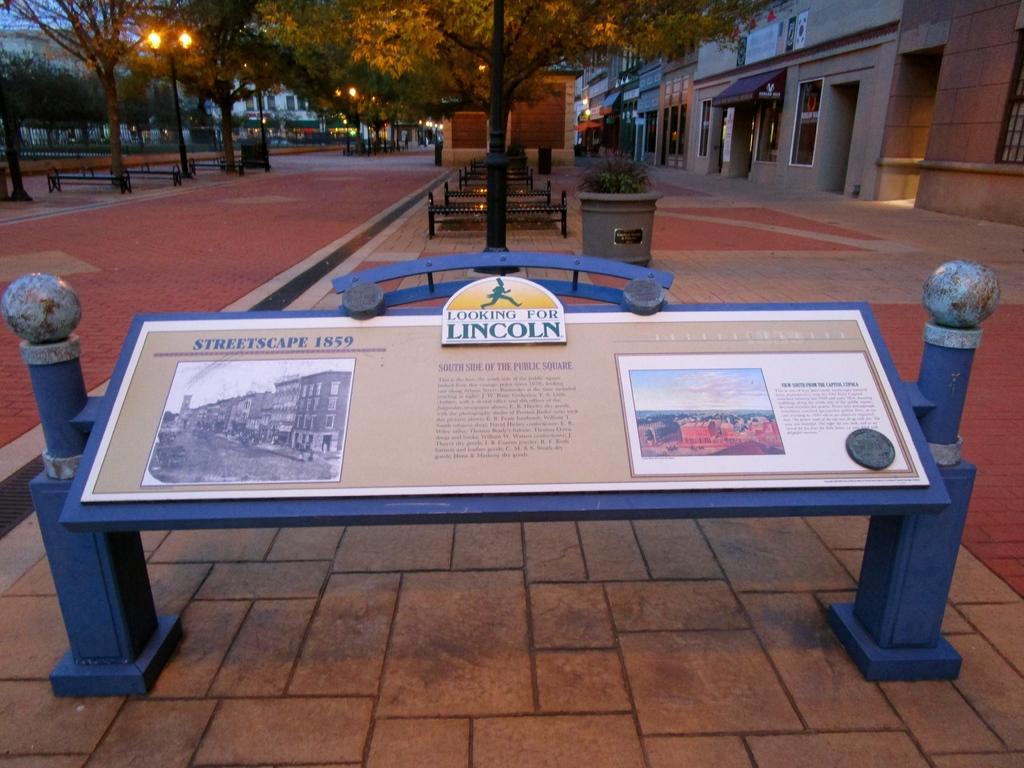Please provide a concise description of this image. In this image, we can see a blue color board, on that there is a poster, in the background we can see some benches and poles, there are some trees, at the right side there are some buildings. 